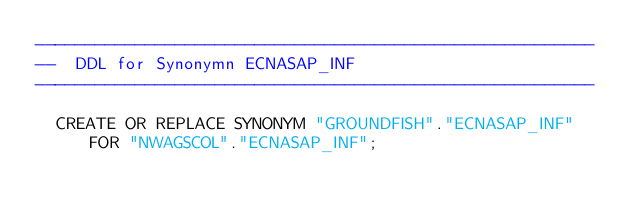<code> <loc_0><loc_0><loc_500><loc_500><_SQL_>--------------------------------------------------------
--  DDL for Synonymn ECNASAP_INF
--------------------------------------------------------

  CREATE OR REPLACE SYNONYM "GROUNDFISH"."ECNASAP_INF" FOR "NWAGSCOL"."ECNASAP_INF";
</code> 